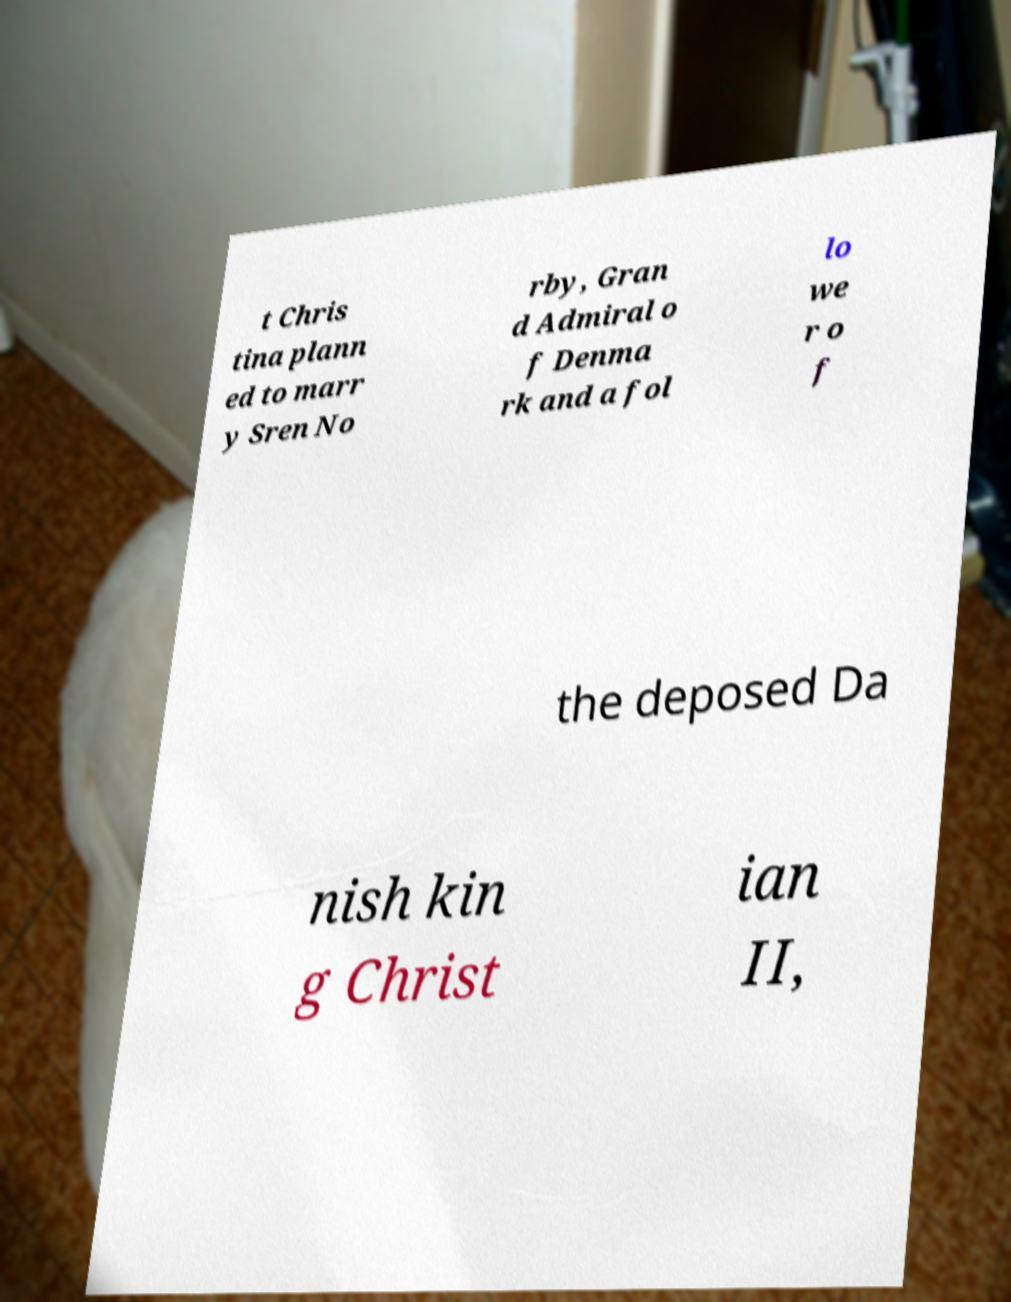Could you extract and type out the text from this image? t Chris tina plann ed to marr y Sren No rby, Gran d Admiral o f Denma rk and a fol lo we r o f the deposed Da nish kin g Christ ian II, 